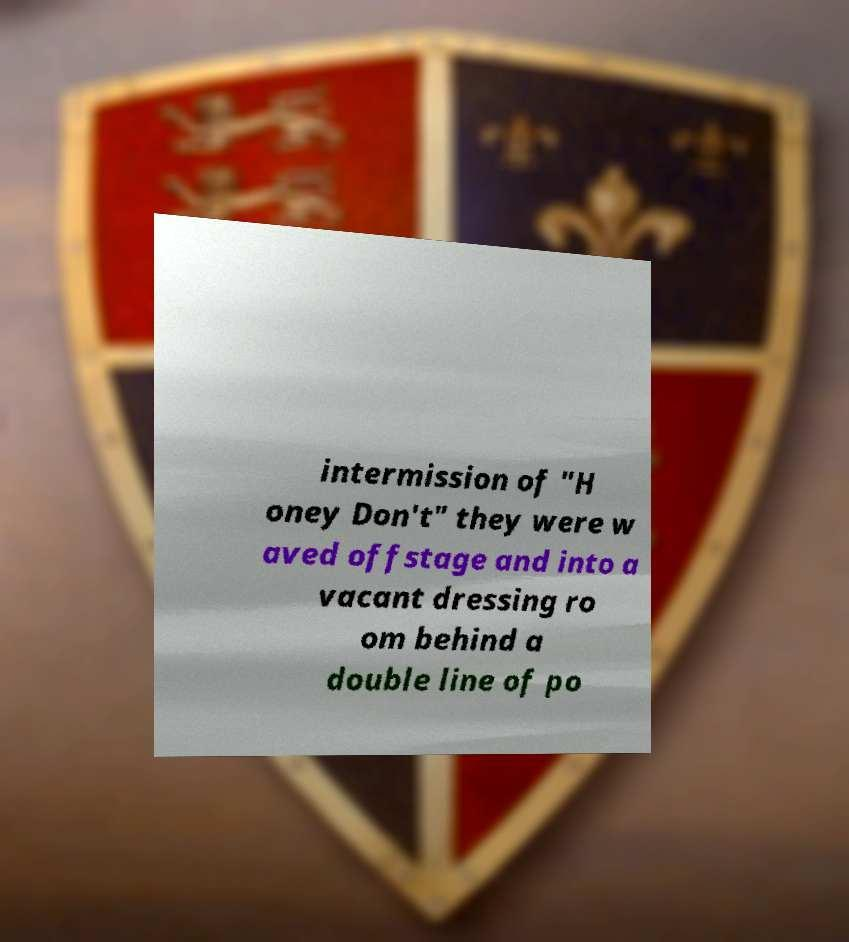What messages or text are displayed in this image? I need them in a readable, typed format. intermission of "H oney Don't" they were w aved offstage and into a vacant dressing ro om behind a double line of po 